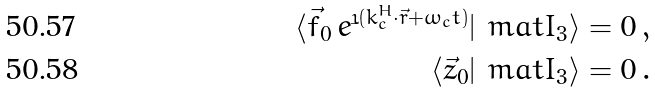Convert formula to latex. <formula><loc_0><loc_0><loc_500><loc_500>\langle \vec { f } _ { 0 } \, e ^ { \dot { \imath } ( { k _ { c } ^ { H } } \cdot \vec { r } + \omega _ { c } t ) } | \ m a t { I } _ { 3 } \rangle = 0 \, , \\ \langle \vec { z } _ { 0 } | \ m a t { I } _ { 3 } \rangle = 0 \, .</formula> 